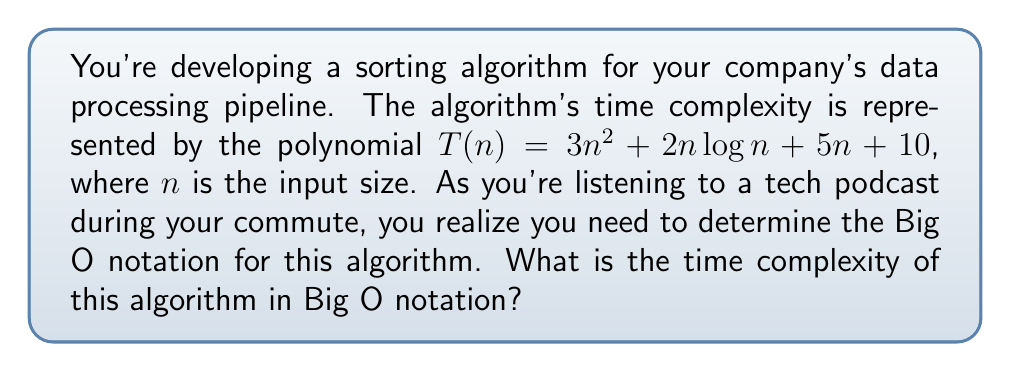Provide a solution to this math problem. To determine the Big O notation, we need to identify the dominant term in the polynomial as $n$ approaches infinity. Let's analyze each term:

1. $3n^2$: This is a quadratic term.
2. $2n\log n$: This is a linearithmic term.
3. $5n$: This is a linear term.
4. $10$: This is a constant term.

As $n$ grows larger, the quadratic term $3n^2$ will dominate all other terms:

$$\lim_{n \to \infty} \frac{3n^2}{2n\log n} = \lim_{n \to \infty} \frac{3n}{2\log n} = \infty$$
$$\lim_{n \to \infty} \frac{3n^2}{5n} = \lim_{n \to \infty} \frac{3n}{5} = \infty$$
$$\lim_{n \to \infty} \frac{3n^2}{10} = \infty$$

Therefore, we can simplify the polynomial to its dominant term:

$$T(n) \approx 3n^2$$

In Big O notation, we drop constant coefficients, so $3n^2$ becomes $O(n^2)$.
Answer: $O(n^2)$ 